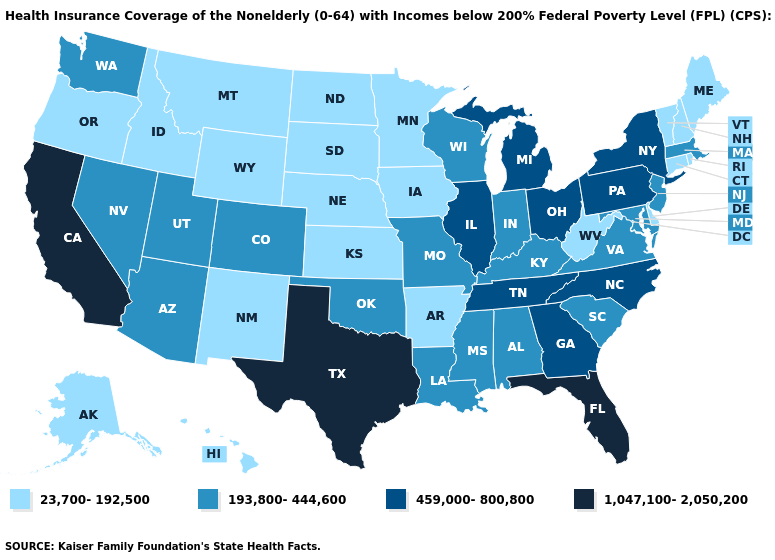Name the states that have a value in the range 193,800-444,600?
Concise answer only. Alabama, Arizona, Colorado, Indiana, Kentucky, Louisiana, Maryland, Massachusetts, Mississippi, Missouri, Nevada, New Jersey, Oklahoma, South Carolina, Utah, Virginia, Washington, Wisconsin. Does the map have missing data?
Write a very short answer. No. Does the map have missing data?
Quick response, please. No. Among the states that border Massachusetts , does New Hampshire have the highest value?
Answer briefly. No. Name the states that have a value in the range 23,700-192,500?
Concise answer only. Alaska, Arkansas, Connecticut, Delaware, Hawaii, Idaho, Iowa, Kansas, Maine, Minnesota, Montana, Nebraska, New Hampshire, New Mexico, North Dakota, Oregon, Rhode Island, South Dakota, Vermont, West Virginia, Wyoming. Does West Virginia have the lowest value in the South?
Short answer required. Yes. Does Arkansas have the lowest value in the USA?
Short answer required. Yes. Does Alaska have the same value as Washington?
Concise answer only. No. What is the value of California?
Write a very short answer. 1,047,100-2,050,200. Among the states that border West Virginia , which have the lowest value?
Be succinct. Kentucky, Maryland, Virginia. What is the value of Wisconsin?
Concise answer only. 193,800-444,600. What is the highest value in the Northeast ?
Give a very brief answer. 459,000-800,800. Does Arizona have the lowest value in the West?
Short answer required. No. What is the value of South Dakota?
Concise answer only. 23,700-192,500. Does the map have missing data?
Write a very short answer. No. 